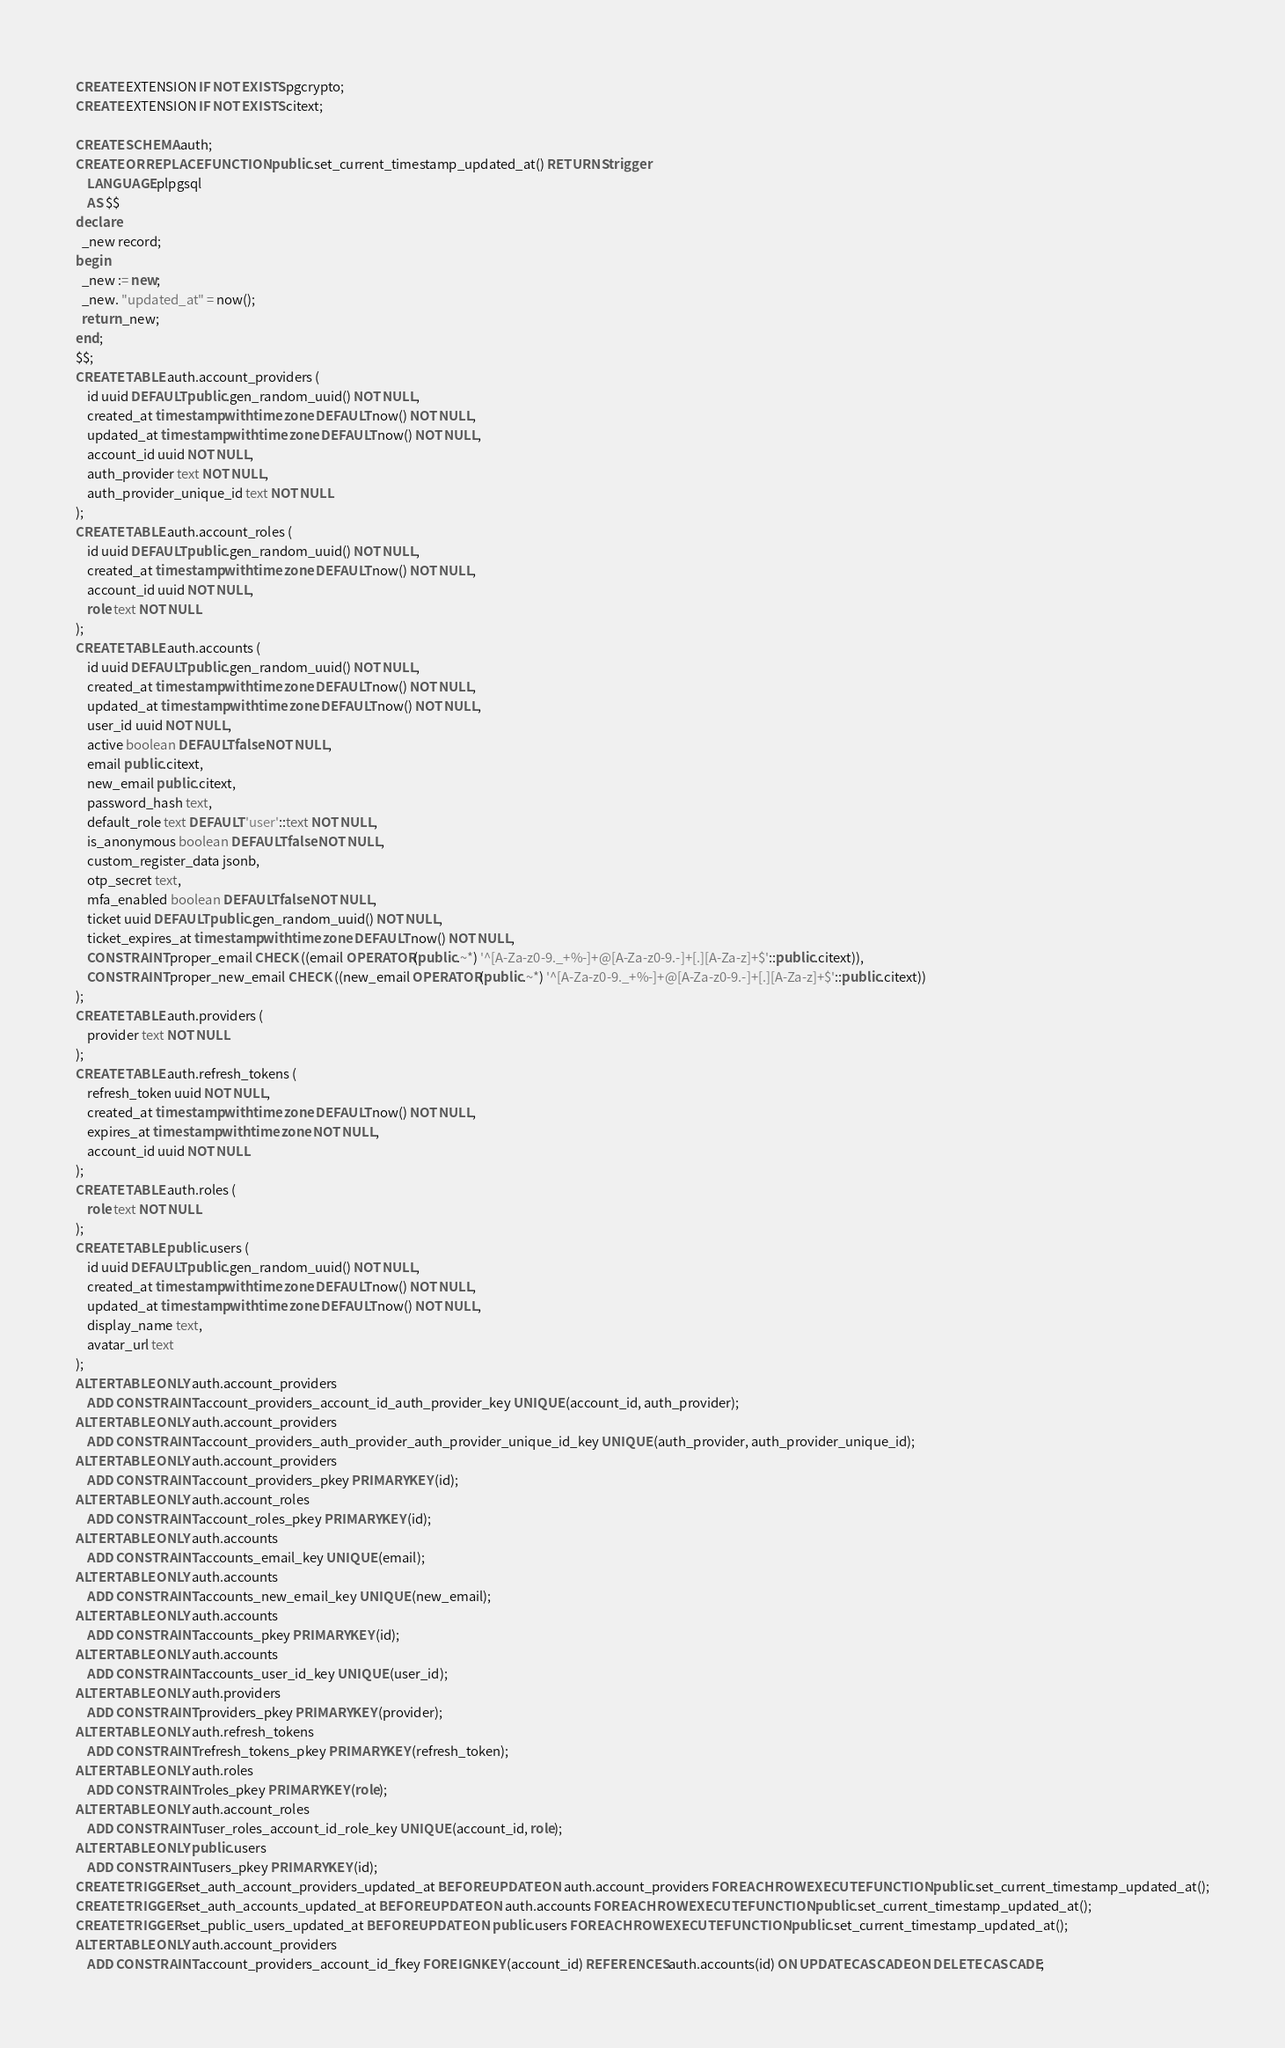Convert code to text. <code><loc_0><loc_0><loc_500><loc_500><_SQL_>CREATE EXTENSION IF NOT EXISTS pgcrypto;
CREATE EXTENSION IF NOT EXISTS citext;

CREATE SCHEMA auth;
CREATE OR REPLACE FUNCTION public.set_current_timestamp_updated_at() RETURNS trigger
    LANGUAGE plpgsql
    AS $$
declare
  _new record;
begin
  _new := new;
  _new. "updated_at" = now();
  return _new;
end;
$$;
CREATE TABLE auth.account_providers (
    id uuid DEFAULT public.gen_random_uuid() NOT NULL,
    created_at timestamp with time zone DEFAULT now() NOT NULL,
    updated_at timestamp with time zone DEFAULT now() NOT NULL,
    account_id uuid NOT NULL,
    auth_provider text NOT NULL,
    auth_provider_unique_id text NOT NULL
);
CREATE TABLE auth.account_roles (
    id uuid DEFAULT public.gen_random_uuid() NOT NULL,
    created_at timestamp with time zone DEFAULT now() NOT NULL,
    account_id uuid NOT NULL,
    role text NOT NULL
);
CREATE TABLE auth.accounts (
    id uuid DEFAULT public.gen_random_uuid() NOT NULL,
    created_at timestamp with time zone DEFAULT now() NOT NULL,
    updated_at timestamp with time zone DEFAULT now() NOT NULL,
    user_id uuid NOT NULL,
    active boolean DEFAULT false NOT NULL,
    email public.citext,
    new_email public.citext,
    password_hash text,
    default_role text DEFAULT 'user'::text NOT NULL,
    is_anonymous boolean DEFAULT false NOT NULL,
    custom_register_data jsonb,
    otp_secret text,
    mfa_enabled boolean DEFAULT false NOT NULL,
    ticket uuid DEFAULT public.gen_random_uuid() NOT NULL,
    ticket_expires_at timestamp with time zone DEFAULT now() NOT NULL,
    CONSTRAINT proper_email CHECK ((email OPERATOR(public.~*) '^[A-Za-z0-9._+%-]+@[A-Za-z0-9.-]+[.][A-Za-z]+$'::public.citext)),
    CONSTRAINT proper_new_email CHECK ((new_email OPERATOR(public.~*) '^[A-Za-z0-9._+%-]+@[A-Za-z0-9.-]+[.][A-Za-z]+$'::public.citext))
);
CREATE TABLE auth.providers (
    provider text NOT NULL
);
CREATE TABLE auth.refresh_tokens (
    refresh_token uuid NOT NULL,
    created_at timestamp with time zone DEFAULT now() NOT NULL,
    expires_at timestamp with time zone NOT NULL,
    account_id uuid NOT NULL
);
CREATE TABLE auth.roles (
    role text NOT NULL
);
CREATE TABLE public.users (
    id uuid DEFAULT public.gen_random_uuid() NOT NULL,
    created_at timestamp with time zone DEFAULT now() NOT NULL,
    updated_at timestamp with time zone DEFAULT now() NOT NULL,
    display_name text,
    avatar_url text
);
ALTER TABLE ONLY auth.account_providers
    ADD CONSTRAINT account_providers_account_id_auth_provider_key UNIQUE (account_id, auth_provider);
ALTER TABLE ONLY auth.account_providers
    ADD CONSTRAINT account_providers_auth_provider_auth_provider_unique_id_key UNIQUE (auth_provider, auth_provider_unique_id);
ALTER TABLE ONLY auth.account_providers
    ADD CONSTRAINT account_providers_pkey PRIMARY KEY (id);
ALTER TABLE ONLY auth.account_roles
    ADD CONSTRAINT account_roles_pkey PRIMARY KEY (id);
ALTER TABLE ONLY auth.accounts
    ADD CONSTRAINT accounts_email_key UNIQUE (email);
ALTER TABLE ONLY auth.accounts
    ADD CONSTRAINT accounts_new_email_key UNIQUE (new_email);
ALTER TABLE ONLY auth.accounts
    ADD CONSTRAINT accounts_pkey PRIMARY KEY (id);
ALTER TABLE ONLY auth.accounts
    ADD CONSTRAINT accounts_user_id_key UNIQUE (user_id);
ALTER TABLE ONLY auth.providers
    ADD CONSTRAINT providers_pkey PRIMARY KEY (provider);
ALTER TABLE ONLY auth.refresh_tokens
    ADD CONSTRAINT refresh_tokens_pkey PRIMARY KEY (refresh_token);
ALTER TABLE ONLY auth.roles
    ADD CONSTRAINT roles_pkey PRIMARY KEY (role);
ALTER TABLE ONLY auth.account_roles
    ADD CONSTRAINT user_roles_account_id_role_key UNIQUE (account_id, role);
ALTER TABLE ONLY public.users
    ADD CONSTRAINT users_pkey PRIMARY KEY (id);
CREATE TRIGGER set_auth_account_providers_updated_at BEFORE UPDATE ON auth.account_providers FOR EACH ROW EXECUTE FUNCTION public.set_current_timestamp_updated_at();
CREATE TRIGGER set_auth_accounts_updated_at BEFORE UPDATE ON auth.accounts FOR EACH ROW EXECUTE FUNCTION public.set_current_timestamp_updated_at();
CREATE TRIGGER set_public_users_updated_at BEFORE UPDATE ON public.users FOR EACH ROW EXECUTE FUNCTION public.set_current_timestamp_updated_at();
ALTER TABLE ONLY auth.account_providers
    ADD CONSTRAINT account_providers_account_id_fkey FOREIGN KEY (account_id) REFERENCES auth.accounts(id) ON UPDATE CASCADE ON DELETE CASCADE;</code> 